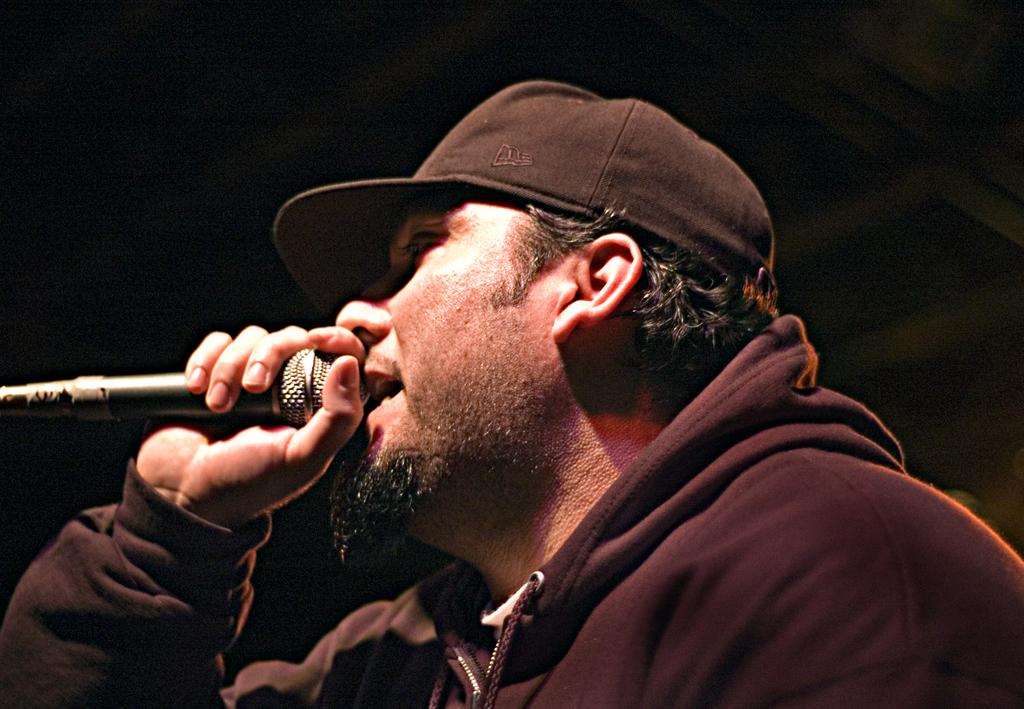Who is the main subject in the image? There is a man in the image. What is the man holding in the image? The man is holding a microphone. What type of soup is the man making in the image? There is no soup present in the image; the man is holding a microphone. What kind of magic trick is the man performing in the image? There is no magic trick being performed in the image; the man is simply holding a microphone. 